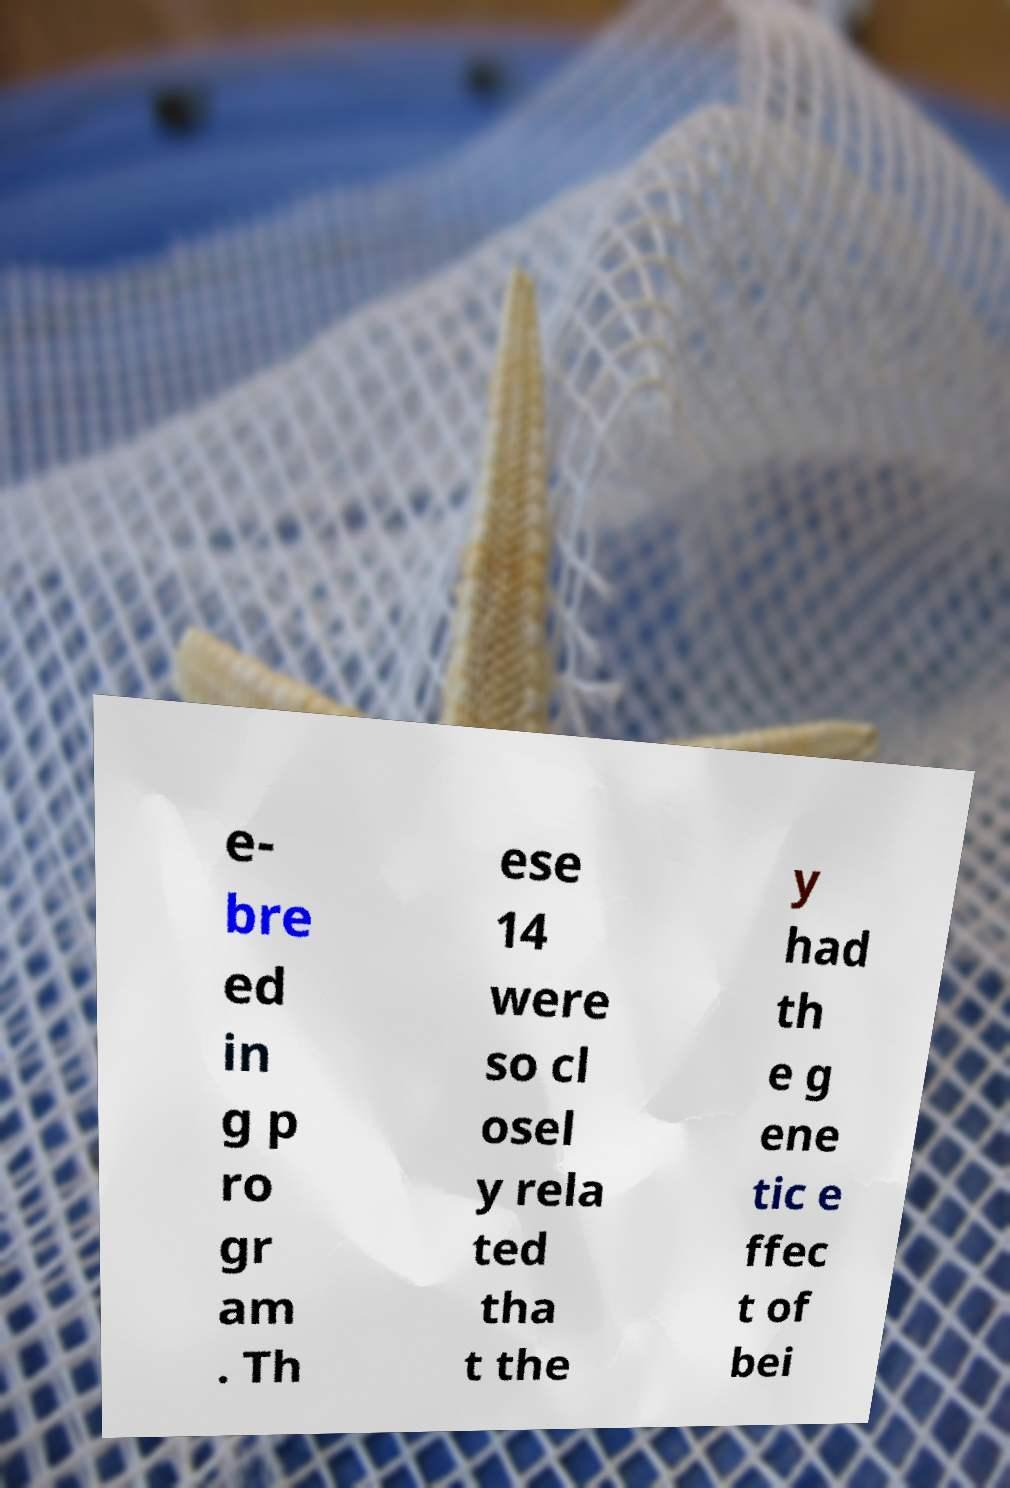Could you extract and type out the text from this image? e- bre ed in g p ro gr am . Th ese 14 were so cl osel y rela ted tha t the y had th e g ene tic e ffec t of bei 